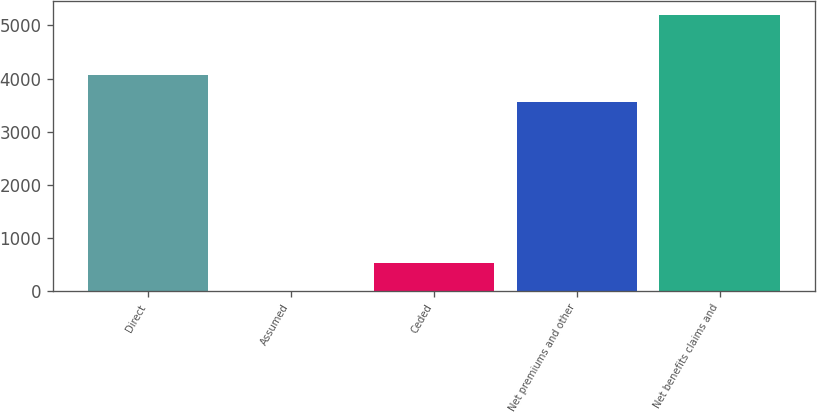Convert chart to OTSL. <chart><loc_0><loc_0><loc_500><loc_500><bar_chart><fcel>Direct<fcel>Assumed<fcel>Ceded<fcel>Net premiums and other<fcel>Net benefits claims and<nl><fcel>4075.58<fcel>3.5<fcel>523.58<fcel>3555.5<fcel>5204.3<nl></chart> 